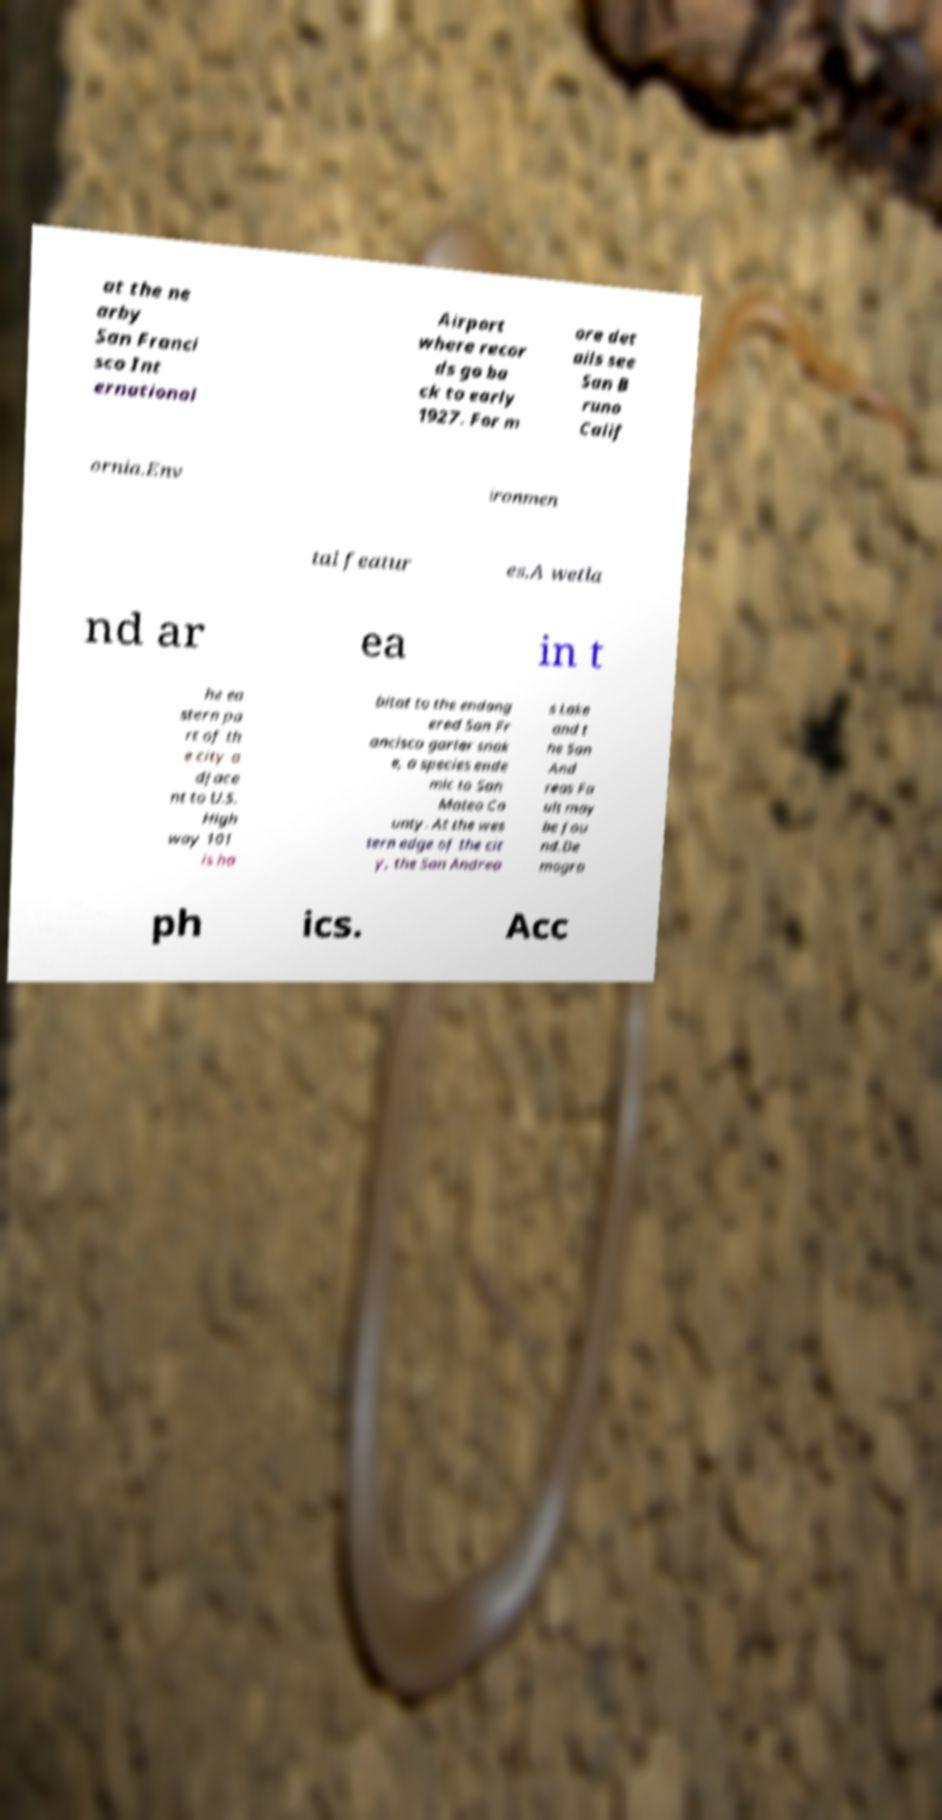What messages or text are displayed in this image? I need them in a readable, typed format. at the ne arby San Franci sco Int ernational Airport where recor ds go ba ck to early 1927. For m ore det ails see San B runo Calif ornia.Env ironmen tal featur es.A wetla nd ar ea in t he ea stern pa rt of th e city a djace nt to U.S. High way 101 is ha bitat to the endang ered San Fr ancisco garter snak e, a species ende mic to San Mateo Co unty. At the wes tern edge of the cit y, the San Andrea s Lake and t he San And reas Fa ult may be fou nd.De mogra ph ics. Acc 